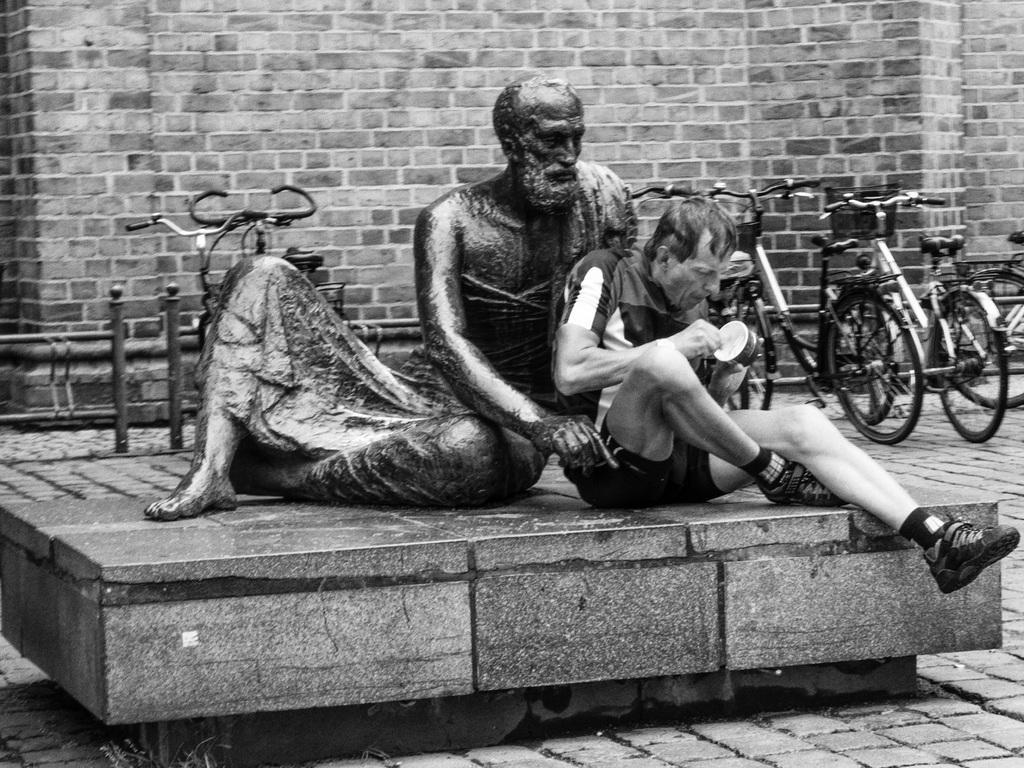Describe this image in one or two sentences. This image is a black and white image. This image is taken outdoors. In the background there is a wall. A few bicycles are parked on the floor. At the bottom of the image there is a floor. In the middle of the image there is a sculpture on the stage and a man is sitting on the stage and holding a bowl in his hands. 